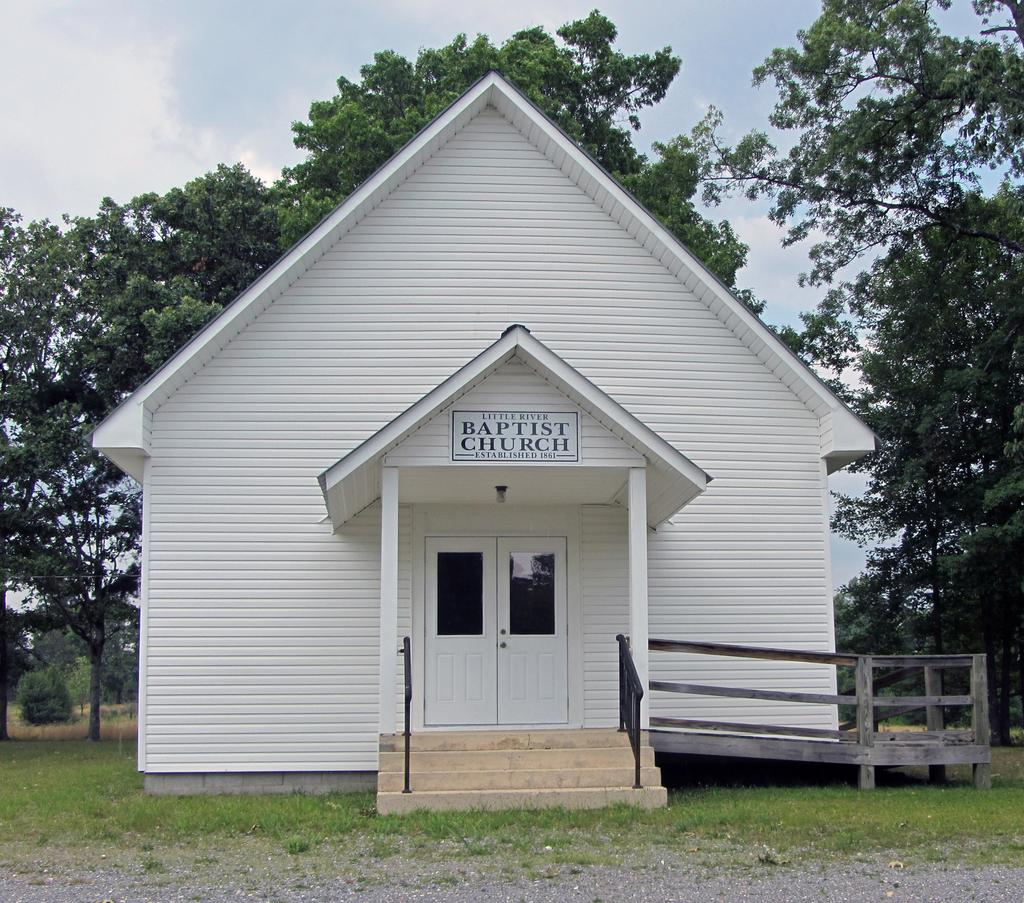What structure is present in the image? There is a shed in the image. What is written or displayed on the shed? The shed has a name board on it. What type of ground surface is visible in the image? There is grass on the ground. What can be seen in the background of the image? There are trees and the sky visible in the background of the image. What type of teeth can be seen on the trees in the image? There are no teeth visible on the trees in the image, as trees do not have teeth. 